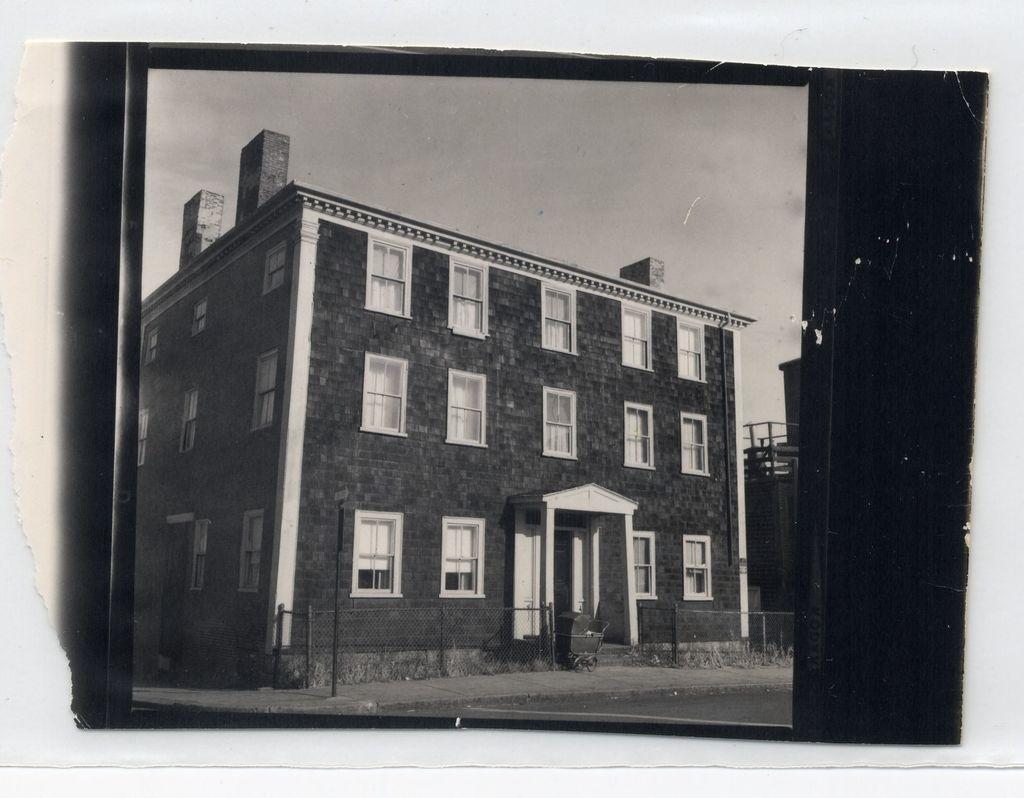How would you summarize this image in a sentence or two? In this image I can see a photograph of a building which has many windows. This is a black and white image. 